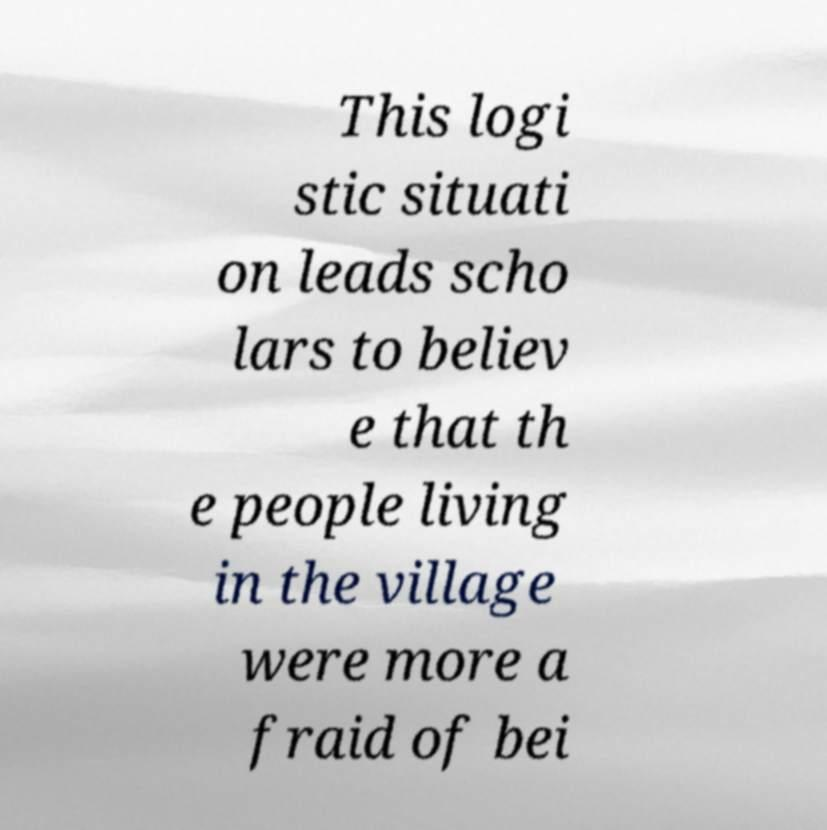Can you read and provide the text displayed in the image?This photo seems to have some interesting text. Can you extract and type it out for me? This logi stic situati on leads scho lars to believ e that th e people living in the village were more a fraid of bei 